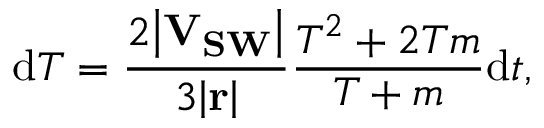<formula> <loc_0><loc_0><loc_500><loc_500>d T = \frac { 2 \left | V _ { S W } \right | } { 3 \left | r \right | } \frac { T ^ { 2 } + 2 T m } { T + m } d t ,</formula> 